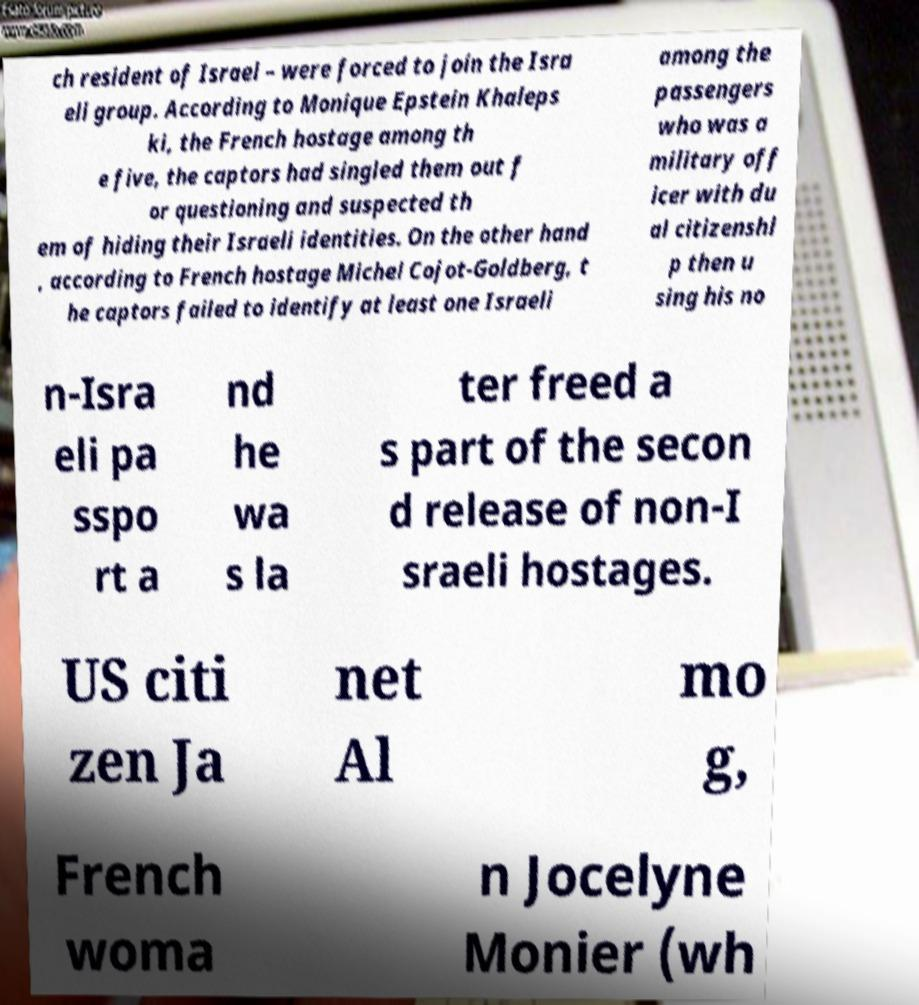There's text embedded in this image that I need extracted. Can you transcribe it verbatim? ch resident of Israel – were forced to join the Isra eli group. According to Monique Epstein Khaleps ki, the French hostage among th e five, the captors had singled them out f or questioning and suspected th em of hiding their Israeli identities. On the other hand , according to French hostage Michel Cojot-Goldberg, t he captors failed to identify at least one Israeli among the passengers who was a military off icer with du al citizenshi p then u sing his no n-Isra eli pa sspo rt a nd he wa s la ter freed a s part of the secon d release of non-I sraeli hostages. US citi zen Ja net Al mo g, French woma n Jocelyne Monier (wh 